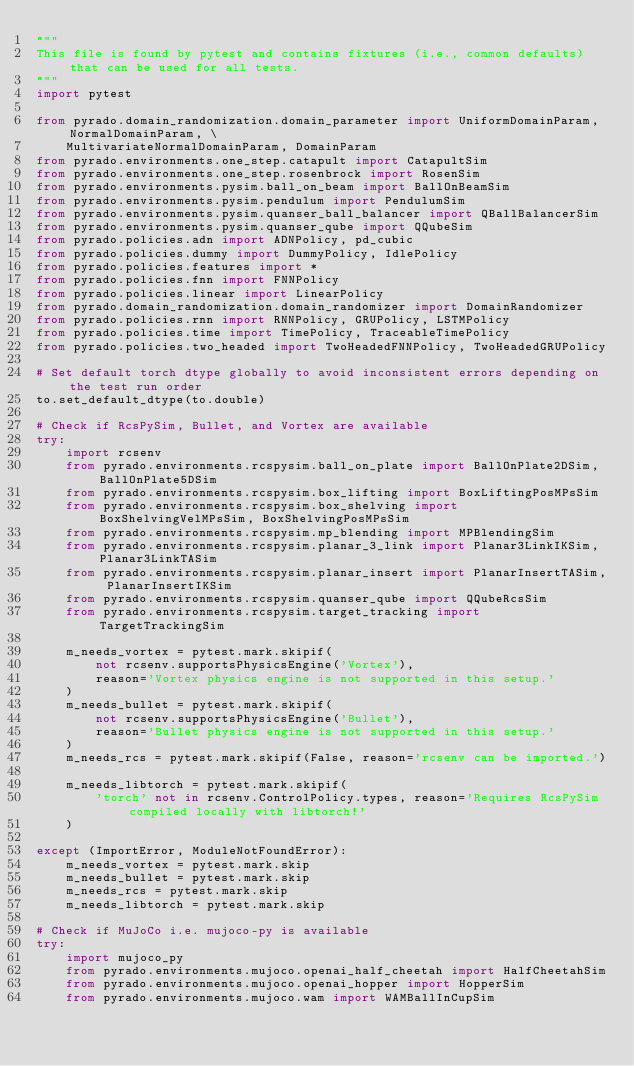Convert code to text. <code><loc_0><loc_0><loc_500><loc_500><_Python_>"""
This file is found by pytest and contains fixtures (i.e., common defaults) that can be used for all tests.
"""
import pytest

from pyrado.domain_randomization.domain_parameter import UniformDomainParam, NormalDomainParam, \
    MultivariateNormalDomainParam, DomainParam
from pyrado.environments.one_step.catapult import CatapultSim
from pyrado.environments.one_step.rosenbrock import RosenSim
from pyrado.environments.pysim.ball_on_beam import BallOnBeamSim
from pyrado.environments.pysim.pendulum import PendulumSim
from pyrado.environments.pysim.quanser_ball_balancer import QBallBalancerSim
from pyrado.environments.pysim.quanser_qube import QQubeSim
from pyrado.policies.adn import ADNPolicy, pd_cubic
from pyrado.policies.dummy import DummyPolicy, IdlePolicy
from pyrado.policies.features import *
from pyrado.policies.fnn import FNNPolicy
from pyrado.policies.linear import LinearPolicy
from pyrado.domain_randomization.domain_randomizer import DomainRandomizer
from pyrado.policies.rnn import RNNPolicy, GRUPolicy, LSTMPolicy
from pyrado.policies.time import TimePolicy, TraceableTimePolicy
from pyrado.policies.two_headed import TwoHeadedFNNPolicy, TwoHeadedGRUPolicy

# Set default torch dtype globally to avoid inconsistent errors depending on the test run order
to.set_default_dtype(to.double)

# Check if RcsPySim, Bullet, and Vortex are available
try:
    import rcsenv
    from pyrado.environments.rcspysim.ball_on_plate import BallOnPlate2DSim, BallOnPlate5DSim
    from pyrado.environments.rcspysim.box_lifting import BoxLiftingPosMPsSim
    from pyrado.environments.rcspysim.box_shelving import BoxShelvingVelMPsSim, BoxShelvingPosMPsSim
    from pyrado.environments.rcspysim.mp_blending import MPBlendingSim
    from pyrado.environments.rcspysim.planar_3_link import Planar3LinkIKSim, Planar3LinkTASim
    from pyrado.environments.rcspysim.planar_insert import PlanarInsertTASim, PlanarInsertIKSim
    from pyrado.environments.rcspysim.quanser_qube import QQubeRcsSim
    from pyrado.environments.rcspysim.target_tracking import TargetTrackingSim

    m_needs_vortex = pytest.mark.skipif(
        not rcsenv.supportsPhysicsEngine('Vortex'),
        reason='Vortex physics engine is not supported in this setup.'
    )
    m_needs_bullet = pytest.mark.skipif(
        not rcsenv.supportsPhysicsEngine('Bullet'),
        reason='Bullet physics engine is not supported in this setup.'
    )
    m_needs_rcs = pytest.mark.skipif(False, reason='rcsenv can be imported.')

    m_needs_libtorch = pytest.mark.skipif(
        'torch' not in rcsenv.ControlPolicy.types, reason='Requires RcsPySim compiled locally with libtorch!'
    )

except (ImportError, ModuleNotFoundError):
    m_needs_vortex = pytest.mark.skip
    m_needs_bullet = pytest.mark.skip
    m_needs_rcs = pytest.mark.skip
    m_needs_libtorch = pytest.mark.skip

# Check if MuJoCo i.e. mujoco-py is available
try:
    import mujoco_py
    from pyrado.environments.mujoco.openai_half_cheetah import HalfCheetahSim
    from pyrado.environments.mujoco.openai_hopper import HopperSim
    from pyrado.environments.mujoco.wam import WAMBallInCupSim
</code> 